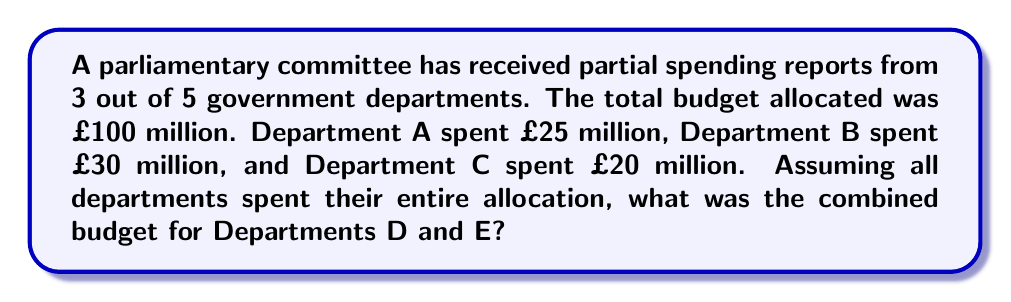Can you answer this question? Let's approach this step-by-step:

1) First, we need to sum up the known expenditures:
   Department A: £25 million
   Department B: £30 million
   Department C: £20 million

   Total known expenditure: $25 + 30 + 20 = £75$ million

2) We know that the total budget allocated was £100 million. This means that all 5 departments together should account for this amount.

3) To find the combined budget for Departments D and E, we need to subtract the known expenditures from the total budget:

   $$\text{Budget D + E} = \text{Total Budget} - \text{Known Expenditures}$$
   $$\text{Budget D + E} = 100 - 75 = £25\text{ million}$$

4) This £25 million represents the combined budget for Departments D and E.
Answer: £25 million 